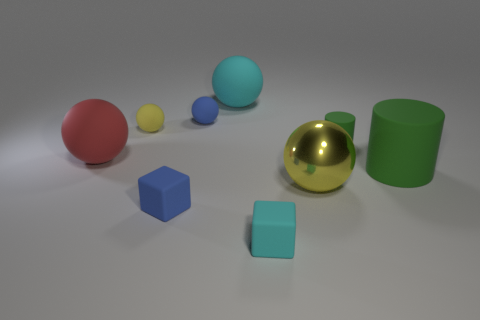Subtract all large cyan rubber spheres. How many spheres are left? 4 Subtract all red spheres. How many spheres are left? 4 Subtract all gray balls. Subtract all yellow cubes. How many balls are left? 5 Add 1 yellow matte spheres. How many objects exist? 10 Subtract all cubes. How many objects are left? 7 Add 4 blue rubber cubes. How many blue rubber cubes exist? 5 Subtract 1 blue spheres. How many objects are left? 8 Subtract all small green shiny things. Subtract all yellow spheres. How many objects are left? 7 Add 4 small cyan objects. How many small cyan objects are left? 5 